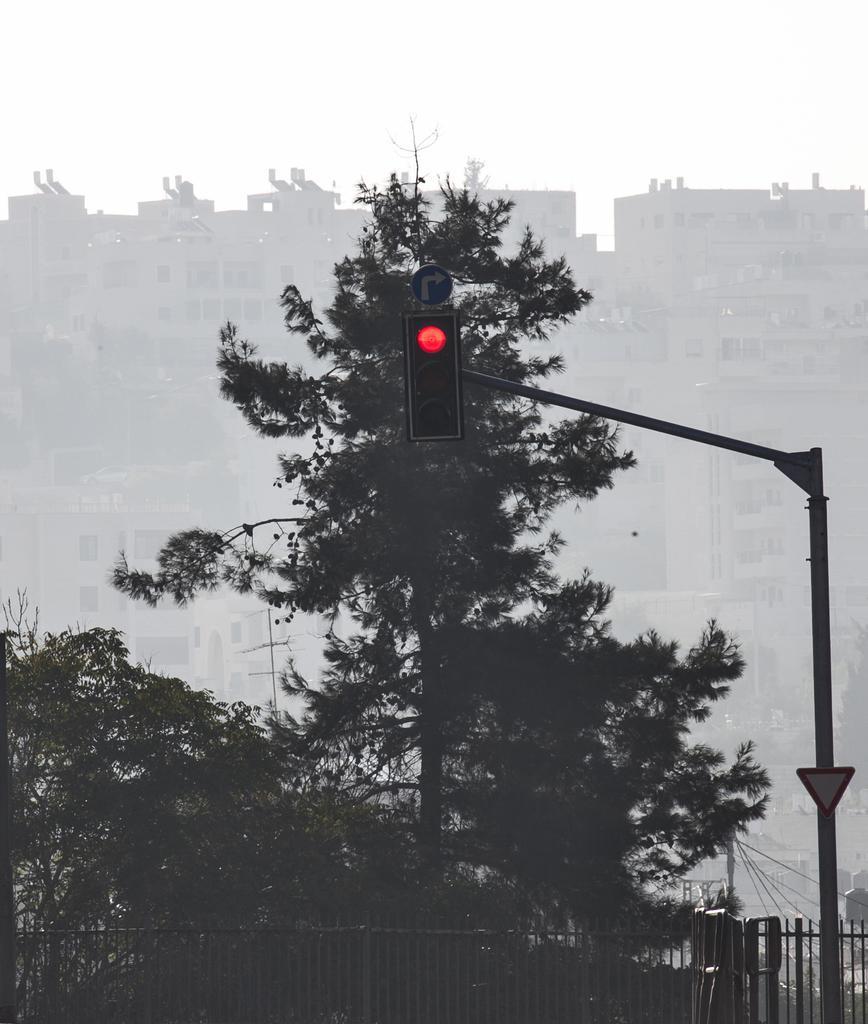Could you give a brief overview of what you see in this image? In this picture we can see few trees, buildings, traffic lights, sign boards and a pole, at the bottom of the image we can see fence. 